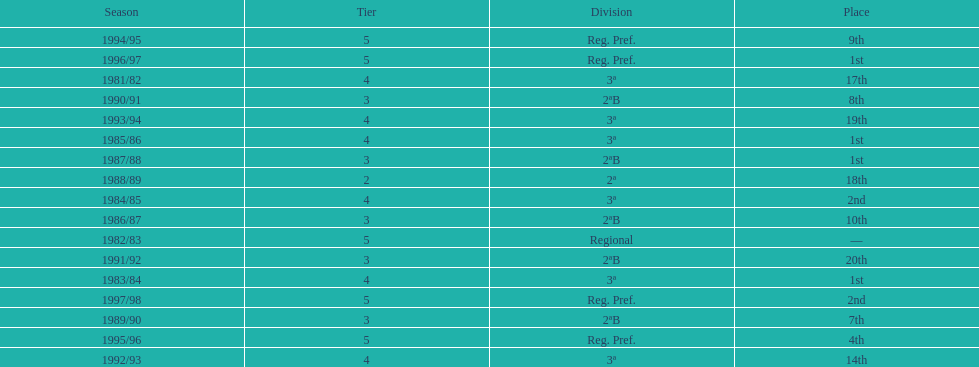How many years were they in tier 3 5. 